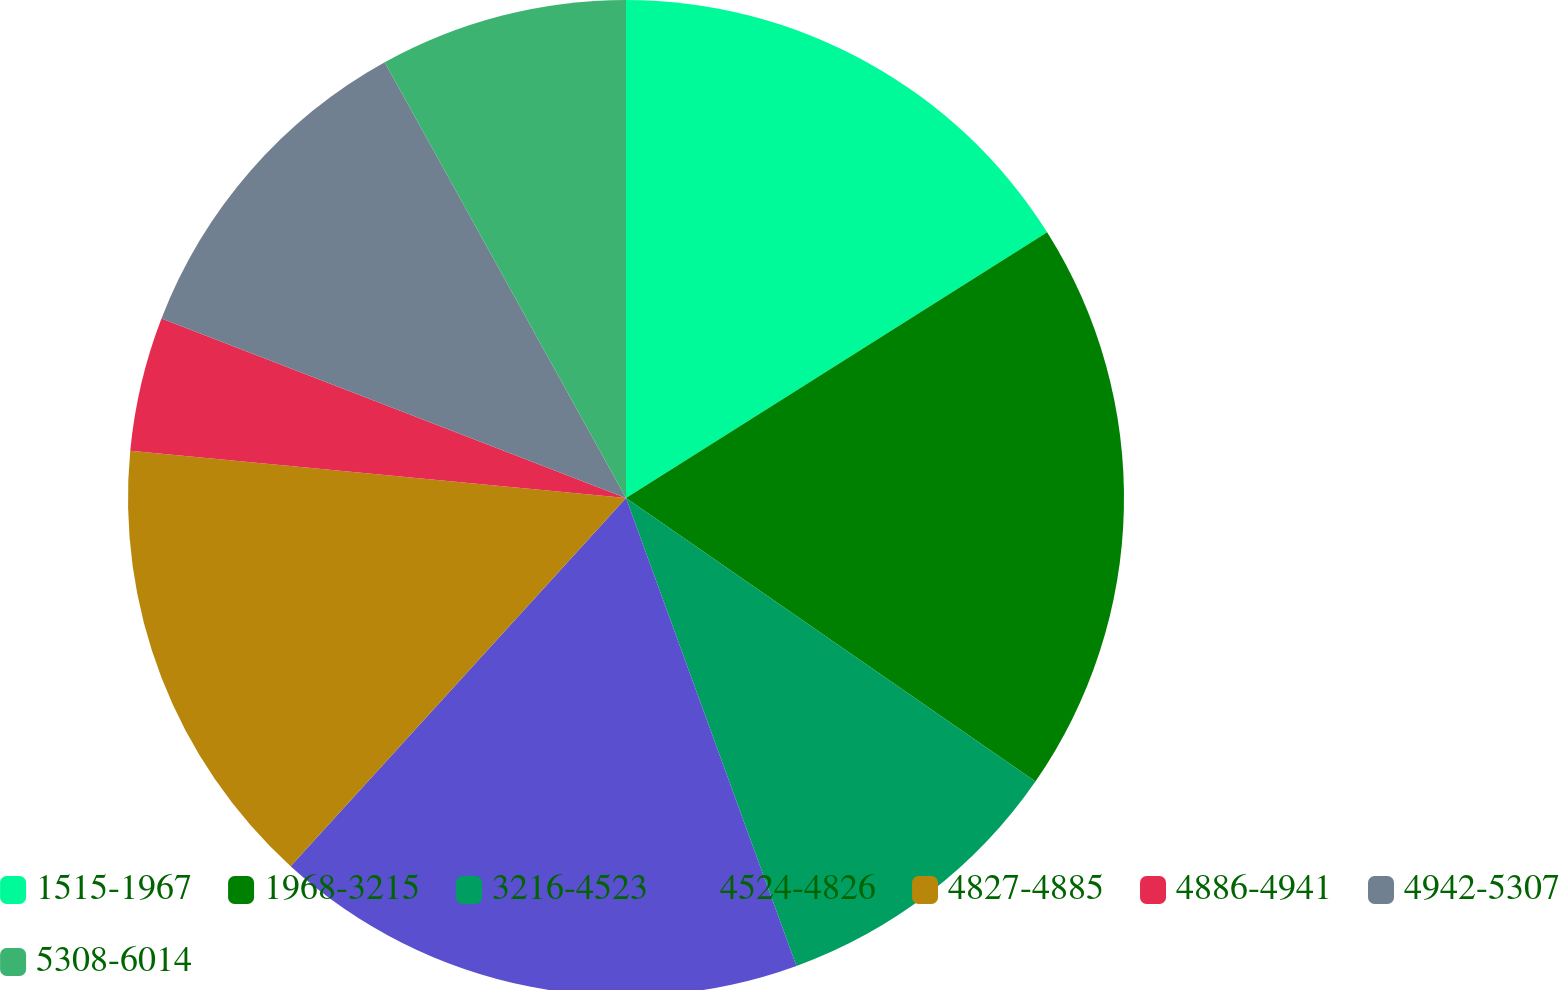Convert chart. <chart><loc_0><loc_0><loc_500><loc_500><pie_chart><fcel>1515-1967<fcel>1968-3215<fcel>3216-4523<fcel>4524-4826<fcel>4827-4885<fcel>4886-4941<fcel>4942-5307<fcel>5308-6014<nl><fcel>16.04%<fcel>18.6%<fcel>9.8%<fcel>17.32%<fcel>14.75%<fcel>4.36%<fcel>11.08%<fcel>8.05%<nl></chart> 